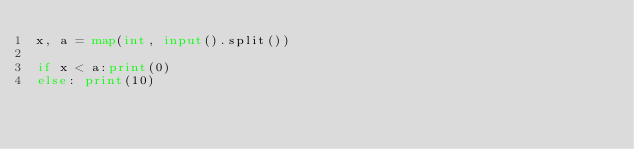<code> <loc_0><loc_0><loc_500><loc_500><_Python_>x, a = map(int, input().split())

if x < a:print(0)
else: print(10)</code> 